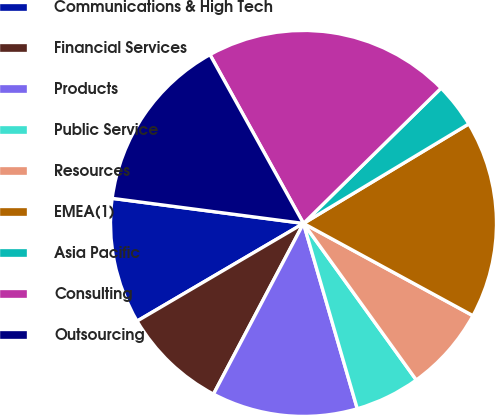Convert chart to OTSL. <chart><loc_0><loc_0><loc_500><loc_500><pie_chart><fcel>Communications & High Tech<fcel>Financial Services<fcel>Products<fcel>Public Service<fcel>Resources<fcel>EMEA(1)<fcel>Asia Pacific<fcel>Consulting<fcel>Outsourcing<nl><fcel>10.52%<fcel>8.83%<fcel>12.22%<fcel>5.44%<fcel>7.13%<fcel>16.56%<fcel>3.74%<fcel>20.69%<fcel>14.87%<nl></chart> 